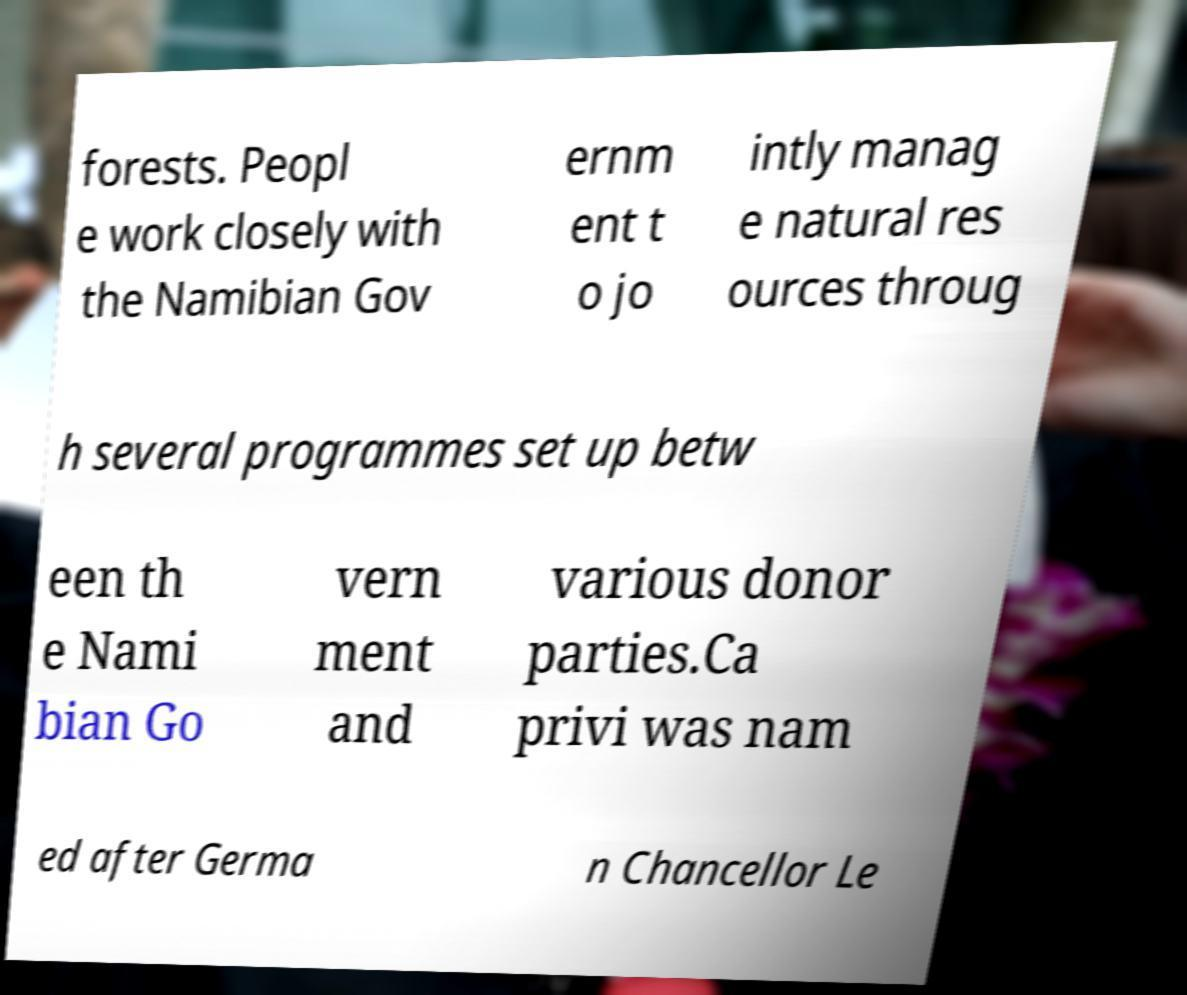For documentation purposes, I need the text within this image transcribed. Could you provide that? forests. Peopl e work closely with the Namibian Gov ernm ent t o jo intly manag e natural res ources throug h several programmes set up betw een th e Nami bian Go vern ment and various donor parties.Ca privi was nam ed after Germa n Chancellor Le 